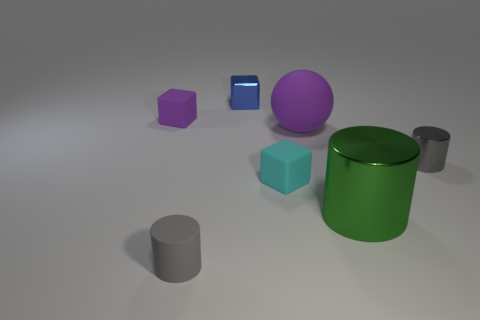Are there any metallic things behind the blue cube?
Your answer should be compact. No. What is the material of the tiny gray cylinder that is in front of the gray object that is on the right side of the small cyan thing?
Provide a short and direct response. Rubber. What size is the other shiny thing that is the same shape as the big green shiny object?
Your answer should be very brief. Small. Is the color of the big shiny thing the same as the big rubber sphere?
Your response must be concise. No. There is a tiny object that is both on the right side of the blue thing and left of the green thing; what color is it?
Provide a succinct answer. Cyan. Does the purple object on the right side of the cyan object have the same size as the green object?
Provide a short and direct response. Yes. Are there any other things that have the same shape as the green metal thing?
Give a very brief answer. Yes. Are the small purple cube and the gray cylinder right of the large purple matte object made of the same material?
Provide a succinct answer. No. How many cyan things are either metallic things or tiny matte blocks?
Offer a very short reply. 1. Are any tiny metal cubes visible?
Offer a terse response. Yes. 